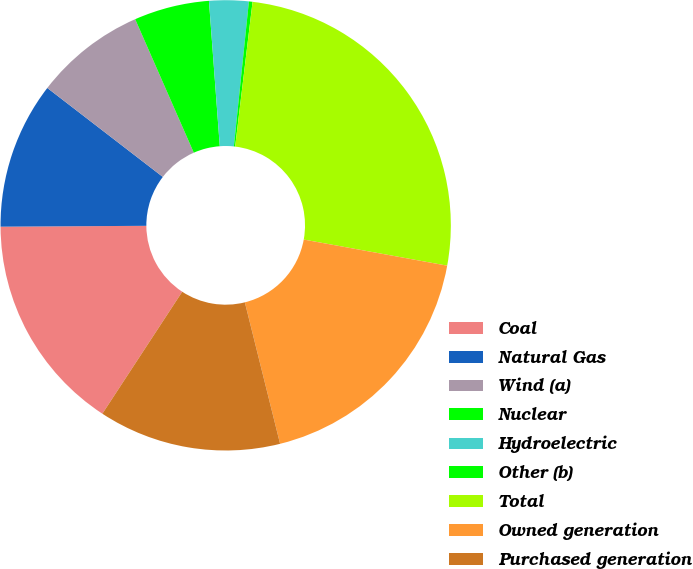Convert chart to OTSL. <chart><loc_0><loc_0><loc_500><loc_500><pie_chart><fcel>Coal<fcel>Natural Gas<fcel>Wind (a)<fcel>Nuclear<fcel>Hydroelectric<fcel>Other (b)<fcel>Total<fcel>Owned generation<fcel>Purchased generation<nl><fcel>15.68%<fcel>10.54%<fcel>7.97%<fcel>5.4%<fcel>2.83%<fcel>0.26%<fcel>25.96%<fcel>18.25%<fcel>13.11%<nl></chart> 